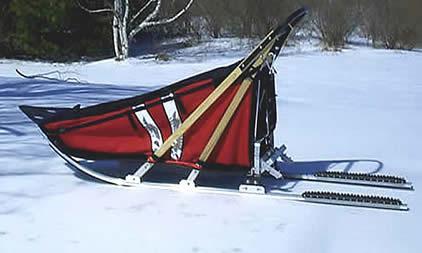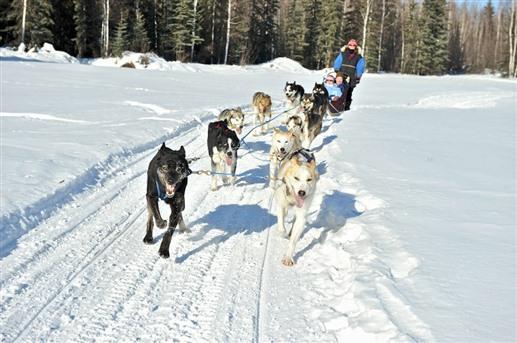The first image is the image on the left, the second image is the image on the right. Considering the images on both sides, is "One image shows dogs that are part of a sled racing team and the other shows only the sled." valid? Answer yes or no. Yes. The first image is the image on the left, the second image is the image on the right. Considering the images on both sides, is "One image shows an empty, unhitched, leftward-facing sled in the foreground, and the other image includes sled dogs in the foreground." valid? Answer yes or no. Yes. 